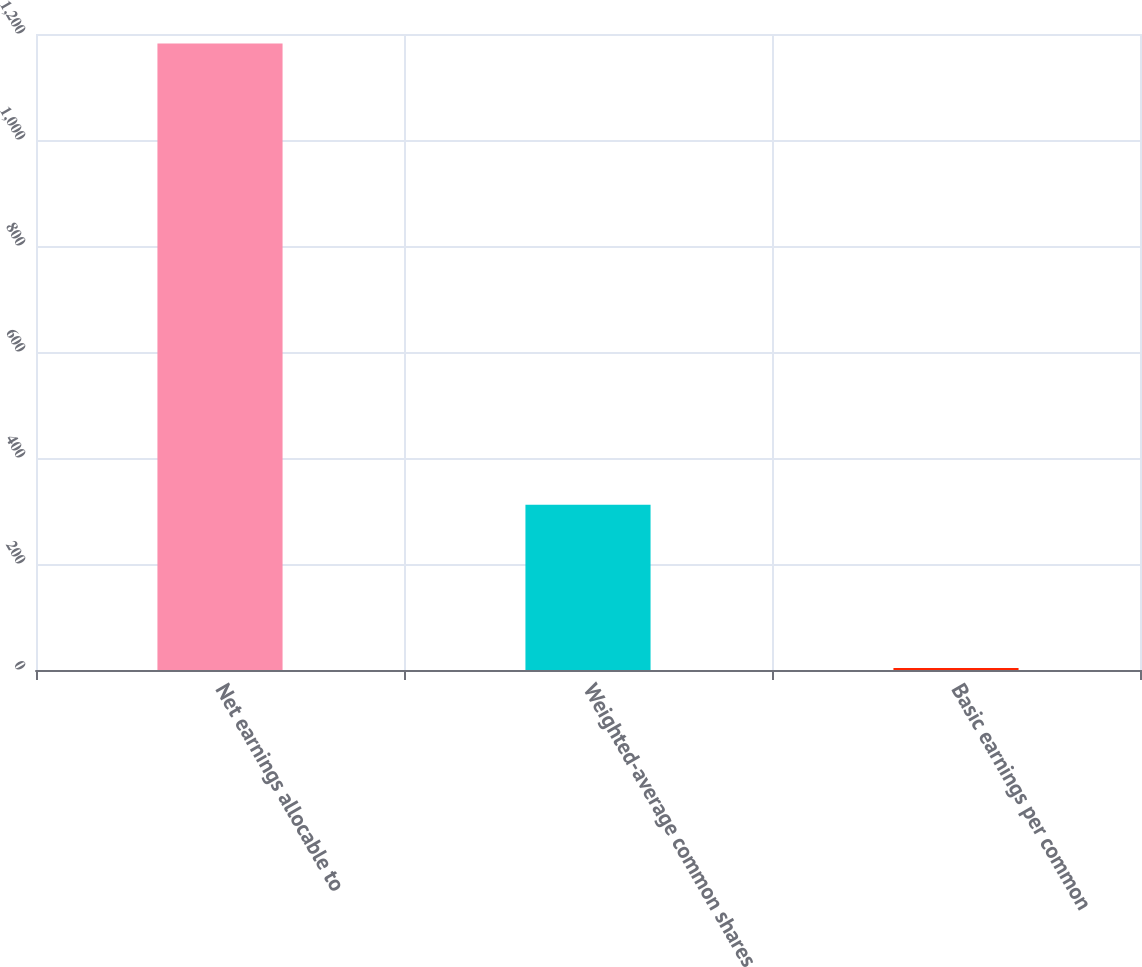Convert chart to OTSL. <chart><loc_0><loc_0><loc_500><loc_500><bar_chart><fcel>Net earnings allocable to<fcel>Weighted-average common shares<fcel>Basic earnings per common<nl><fcel>1182<fcel>312<fcel>3.78<nl></chart> 